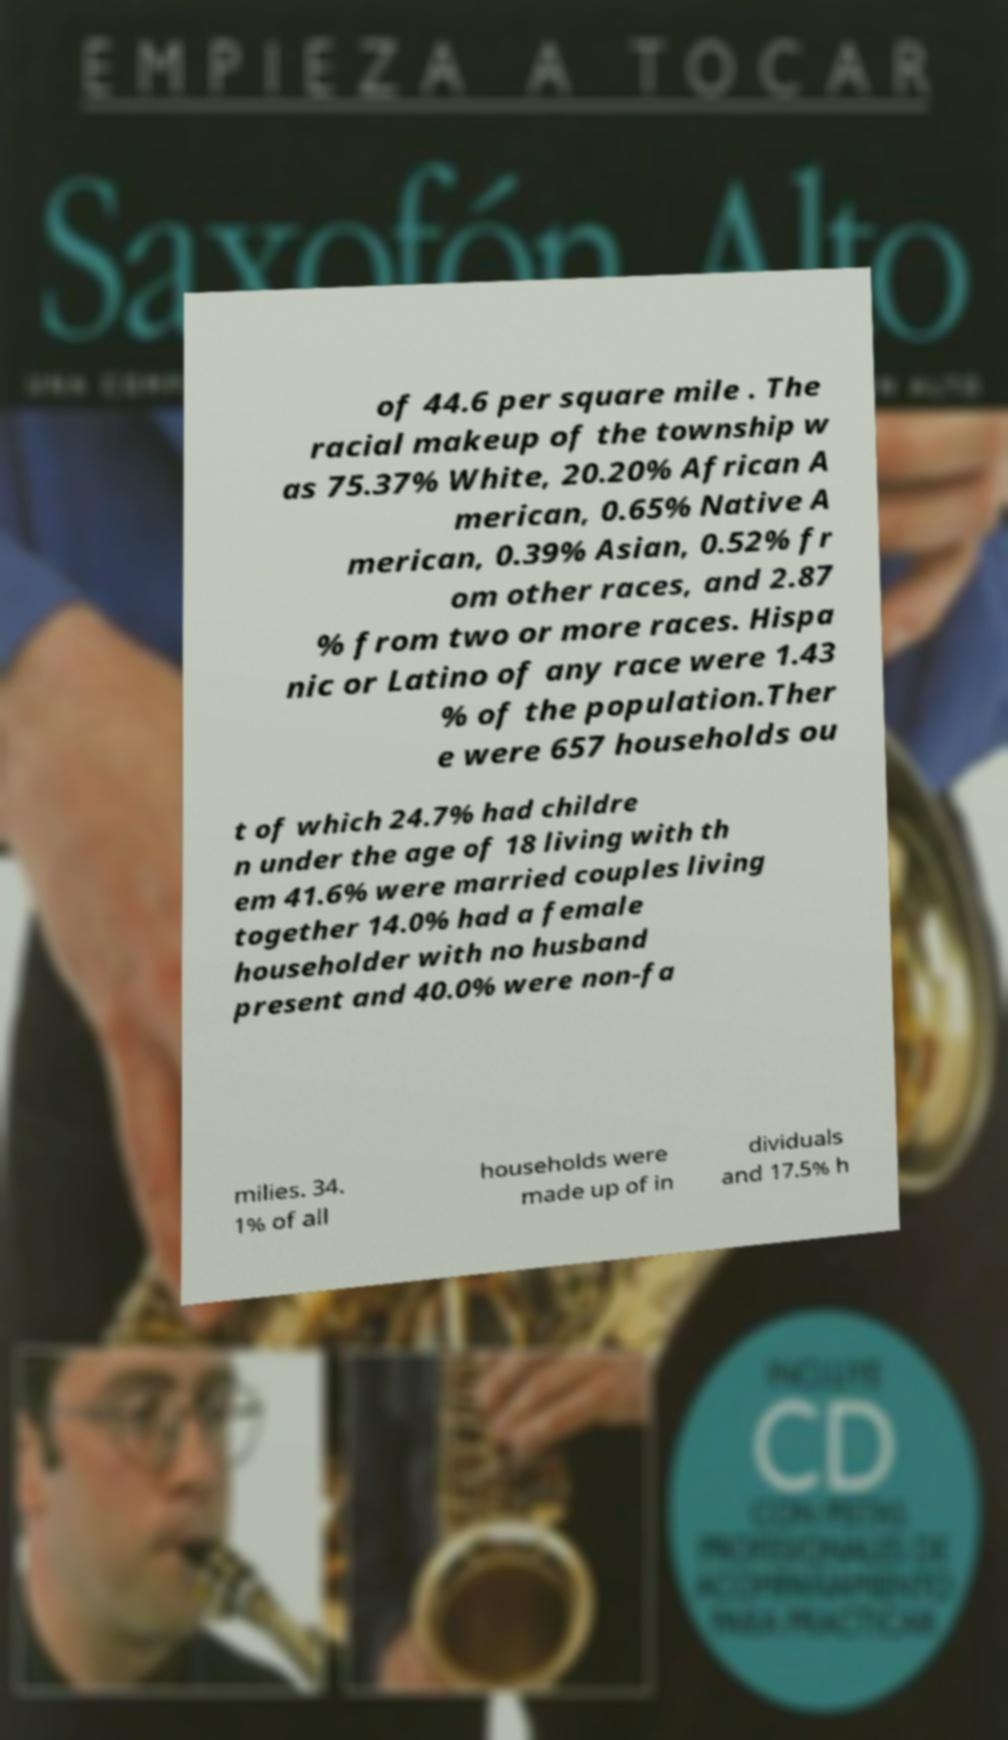There's text embedded in this image that I need extracted. Can you transcribe it verbatim? of 44.6 per square mile . The racial makeup of the township w as 75.37% White, 20.20% African A merican, 0.65% Native A merican, 0.39% Asian, 0.52% fr om other races, and 2.87 % from two or more races. Hispa nic or Latino of any race were 1.43 % of the population.Ther e were 657 households ou t of which 24.7% had childre n under the age of 18 living with th em 41.6% were married couples living together 14.0% had a female householder with no husband present and 40.0% were non-fa milies. 34. 1% of all households were made up of in dividuals and 17.5% h 